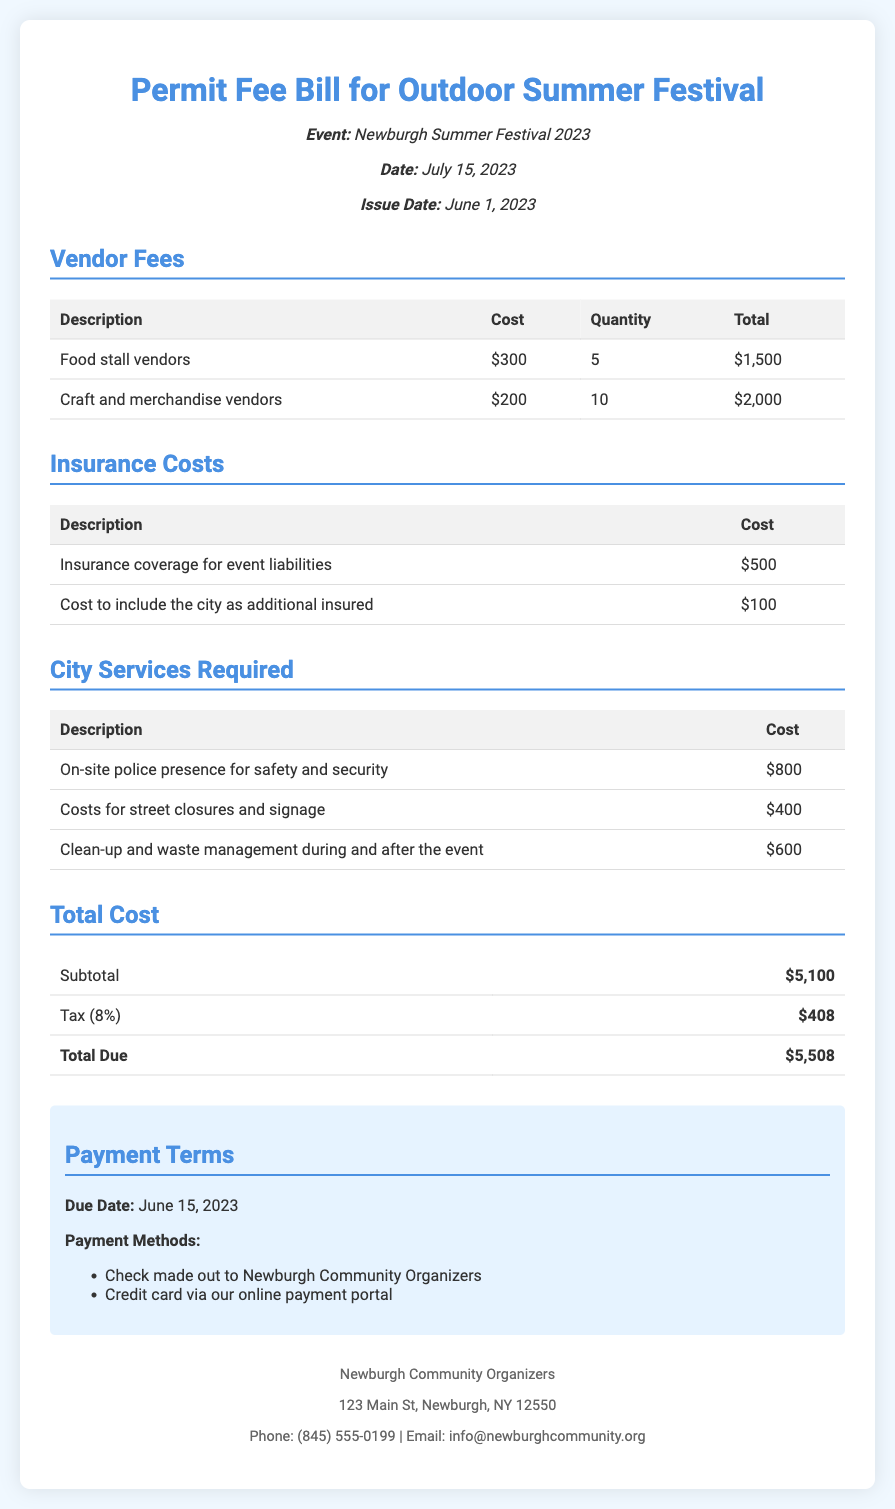What is the total cost of vendor fees? The total cost of vendor fees is calculated from the food stall and craft vendor totals, which are $1500 and $2000 respectively.
Answer: $3500 What is the total due for the permit? The total due is the final amount listed at the bottom of the bill after adding tax to the subtotal.
Answer: $5508 How many food stall vendors are there? The document specifies 5 food stall vendors in the vendor fees section.
Answer: 5 What is the cost for the on-site police presence? The cost for the on-site police presence is listed in the city services required section of the document.
Answer: $800 What is the due date for payment? The due date for payment is explicitly stated in the payment terms section of the document.
Answer: June 15, 2023 What is the quantity of craft and merchandise vendors? The document provides the quantity of craft and merchandise vendors in the vendor fees section.
Answer: 10 What is the total cost of insurance? The total cost of insurance is the sum of the two insurance line items presented in the insurance costs table.
Answer: $600 What is the tax rate applied to the subtotal? The tax rate is mentioned just before the total due section of the document.
Answer: 8% What are the payment methods listed? The document lists two specific payment methods in the payment terms section.
Answer: Check, Credit card 